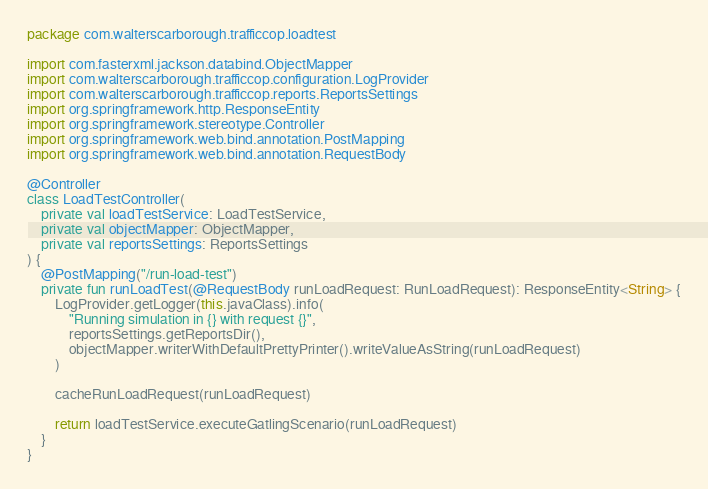Convert code to text. <code><loc_0><loc_0><loc_500><loc_500><_Kotlin_>package com.walterscarborough.trafficcop.loadtest

import com.fasterxml.jackson.databind.ObjectMapper
import com.walterscarborough.trafficcop.configuration.LogProvider
import com.walterscarborough.trafficcop.reports.ReportsSettings
import org.springframework.http.ResponseEntity
import org.springframework.stereotype.Controller
import org.springframework.web.bind.annotation.PostMapping
import org.springframework.web.bind.annotation.RequestBody

@Controller
class LoadTestController(
    private val loadTestService: LoadTestService,
    private val objectMapper: ObjectMapper,
    private val reportsSettings: ReportsSettings
) {
    @PostMapping("/run-load-test")
    private fun runLoadTest(@RequestBody runLoadRequest: RunLoadRequest): ResponseEntity<String> {
        LogProvider.getLogger(this.javaClass).info(
            "Running simulation in {} with request {}",
            reportsSettings.getReportsDir(),
            objectMapper.writerWithDefaultPrettyPrinter().writeValueAsString(runLoadRequest)
        )

        cacheRunLoadRequest(runLoadRequest)

        return loadTestService.executeGatlingScenario(runLoadRequest)
    }
}
</code> 